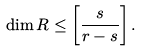<formula> <loc_0><loc_0><loc_500><loc_500>\dim R \leq \left [ \frac { s } { r - s } \right ] .</formula> 